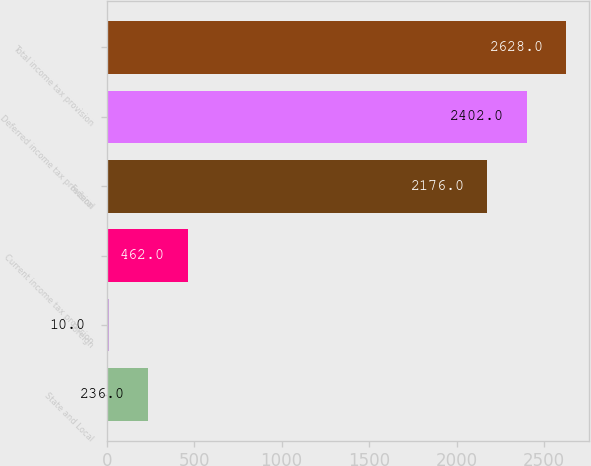Convert chart. <chart><loc_0><loc_0><loc_500><loc_500><bar_chart><fcel>State and Local<fcel>Foreign<fcel>Current income tax provision<fcel>Federal<fcel>Deferred income tax provision<fcel>Total income tax provision<nl><fcel>236<fcel>10<fcel>462<fcel>2176<fcel>2402<fcel>2628<nl></chart> 